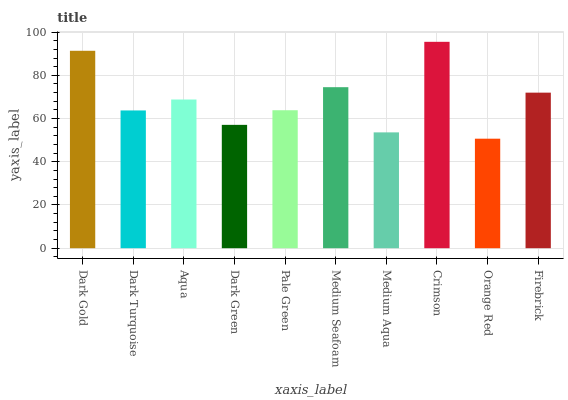Is Orange Red the minimum?
Answer yes or no. Yes. Is Crimson the maximum?
Answer yes or no. Yes. Is Dark Turquoise the minimum?
Answer yes or no. No. Is Dark Turquoise the maximum?
Answer yes or no. No. Is Dark Gold greater than Dark Turquoise?
Answer yes or no. Yes. Is Dark Turquoise less than Dark Gold?
Answer yes or no. Yes. Is Dark Turquoise greater than Dark Gold?
Answer yes or no. No. Is Dark Gold less than Dark Turquoise?
Answer yes or no. No. Is Aqua the high median?
Answer yes or no. Yes. Is Pale Green the low median?
Answer yes or no. Yes. Is Dark Turquoise the high median?
Answer yes or no. No. Is Crimson the low median?
Answer yes or no. No. 